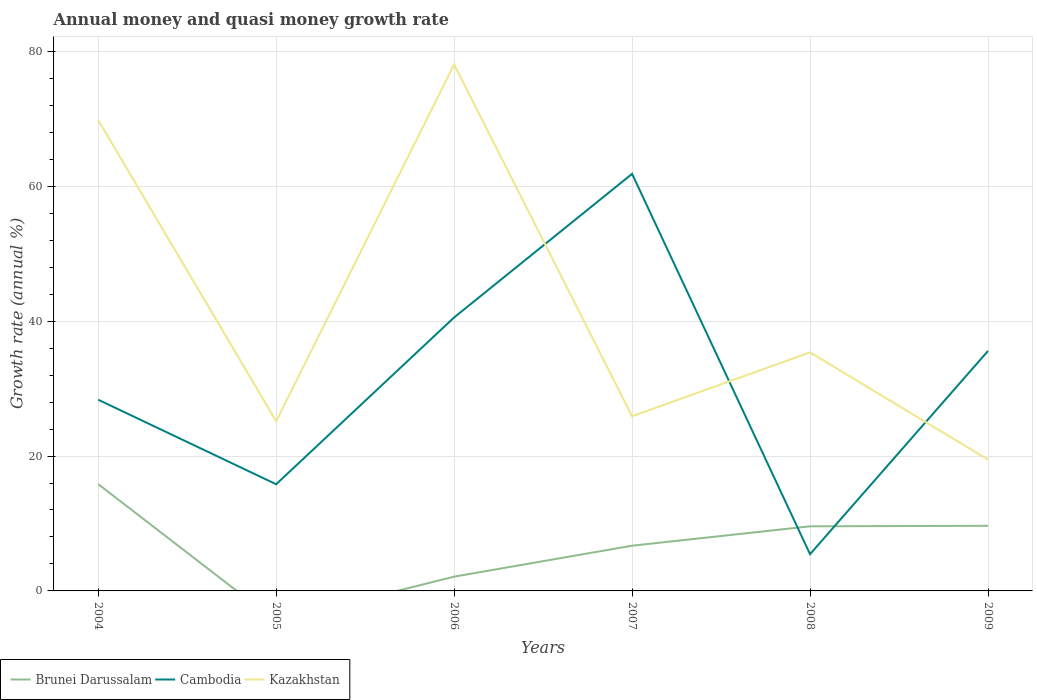How many different coloured lines are there?
Offer a terse response. 3. Is the number of lines equal to the number of legend labels?
Keep it short and to the point. No. Across all years, what is the maximum growth rate in Kazakhstan?
Your answer should be very brief. 19.47. What is the total growth rate in Cambodia in the graph?
Offer a very short reply. 26.25. What is the difference between the highest and the second highest growth rate in Cambodia?
Ensure brevity in your answer.  56.39. Is the growth rate in Cambodia strictly greater than the growth rate in Brunei Darussalam over the years?
Your answer should be compact. No. How many years are there in the graph?
Your answer should be very brief. 6. What is the difference between two consecutive major ticks on the Y-axis?
Your answer should be very brief. 20. How many legend labels are there?
Provide a short and direct response. 3. How are the legend labels stacked?
Give a very brief answer. Horizontal. What is the title of the graph?
Ensure brevity in your answer.  Annual money and quasi money growth rate. What is the label or title of the X-axis?
Your answer should be compact. Years. What is the label or title of the Y-axis?
Offer a terse response. Growth rate (annual %). What is the Growth rate (annual %) in Brunei Darussalam in 2004?
Give a very brief answer. 15.83. What is the Growth rate (annual %) in Cambodia in 2004?
Make the answer very short. 28.35. What is the Growth rate (annual %) of Kazakhstan in 2004?
Keep it short and to the point. 69.81. What is the Growth rate (annual %) of Brunei Darussalam in 2005?
Give a very brief answer. 0. What is the Growth rate (annual %) in Cambodia in 2005?
Your answer should be compact. 15.82. What is the Growth rate (annual %) in Kazakhstan in 2005?
Offer a terse response. 25.16. What is the Growth rate (annual %) of Brunei Darussalam in 2006?
Provide a succinct answer. 2.12. What is the Growth rate (annual %) of Cambodia in 2006?
Offer a very short reply. 40.55. What is the Growth rate (annual %) in Kazakhstan in 2006?
Offer a very short reply. 78.06. What is the Growth rate (annual %) in Brunei Darussalam in 2007?
Ensure brevity in your answer.  6.71. What is the Growth rate (annual %) of Cambodia in 2007?
Offer a terse response. 61.84. What is the Growth rate (annual %) in Kazakhstan in 2007?
Provide a succinct answer. 25.89. What is the Growth rate (annual %) in Brunei Darussalam in 2008?
Offer a terse response. 9.58. What is the Growth rate (annual %) in Cambodia in 2008?
Your answer should be compact. 5.45. What is the Growth rate (annual %) of Kazakhstan in 2008?
Your answer should be compact. 35.37. What is the Growth rate (annual %) in Brunei Darussalam in 2009?
Your answer should be compact. 9.66. What is the Growth rate (annual %) of Cambodia in 2009?
Offer a terse response. 35.58. What is the Growth rate (annual %) of Kazakhstan in 2009?
Your answer should be compact. 19.47. Across all years, what is the maximum Growth rate (annual %) of Brunei Darussalam?
Provide a succinct answer. 15.83. Across all years, what is the maximum Growth rate (annual %) of Cambodia?
Give a very brief answer. 61.84. Across all years, what is the maximum Growth rate (annual %) in Kazakhstan?
Your response must be concise. 78.06. Across all years, what is the minimum Growth rate (annual %) of Cambodia?
Offer a very short reply. 5.45. Across all years, what is the minimum Growth rate (annual %) in Kazakhstan?
Offer a very short reply. 19.47. What is the total Growth rate (annual %) of Brunei Darussalam in the graph?
Your response must be concise. 43.89. What is the total Growth rate (annual %) in Cambodia in the graph?
Offer a terse response. 187.58. What is the total Growth rate (annual %) in Kazakhstan in the graph?
Provide a short and direct response. 253.76. What is the difference between the Growth rate (annual %) in Cambodia in 2004 and that in 2005?
Your answer should be very brief. 12.53. What is the difference between the Growth rate (annual %) in Kazakhstan in 2004 and that in 2005?
Give a very brief answer. 44.64. What is the difference between the Growth rate (annual %) of Brunei Darussalam in 2004 and that in 2006?
Offer a very short reply. 13.72. What is the difference between the Growth rate (annual %) of Cambodia in 2004 and that in 2006?
Offer a very short reply. -12.2. What is the difference between the Growth rate (annual %) in Kazakhstan in 2004 and that in 2006?
Your response must be concise. -8.25. What is the difference between the Growth rate (annual %) of Brunei Darussalam in 2004 and that in 2007?
Your answer should be compact. 9.13. What is the difference between the Growth rate (annual %) in Cambodia in 2004 and that in 2007?
Give a very brief answer. -33.49. What is the difference between the Growth rate (annual %) of Kazakhstan in 2004 and that in 2007?
Ensure brevity in your answer.  43.91. What is the difference between the Growth rate (annual %) in Brunei Darussalam in 2004 and that in 2008?
Give a very brief answer. 6.26. What is the difference between the Growth rate (annual %) of Cambodia in 2004 and that in 2008?
Keep it short and to the point. 22.9. What is the difference between the Growth rate (annual %) of Kazakhstan in 2004 and that in 2008?
Offer a very short reply. 34.44. What is the difference between the Growth rate (annual %) in Brunei Darussalam in 2004 and that in 2009?
Your answer should be very brief. 6.18. What is the difference between the Growth rate (annual %) in Cambodia in 2004 and that in 2009?
Your response must be concise. -7.23. What is the difference between the Growth rate (annual %) in Kazakhstan in 2004 and that in 2009?
Offer a terse response. 50.34. What is the difference between the Growth rate (annual %) of Cambodia in 2005 and that in 2006?
Your answer should be compact. -24.73. What is the difference between the Growth rate (annual %) in Kazakhstan in 2005 and that in 2006?
Offer a very short reply. -52.9. What is the difference between the Growth rate (annual %) in Cambodia in 2005 and that in 2007?
Ensure brevity in your answer.  -46.02. What is the difference between the Growth rate (annual %) in Kazakhstan in 2005 and that in 2007?
Offer a very short reply. -0.73. What is the difference between the Growth rate (annual %) in Cambodia in 2005 and that in 2008?
Provide a succinct answer. 10.37. What is the difference between the Growth rate (annual %) in Kazakhstan in 2005 and that in 2008?
Provide a succinct answer. -10.2. What is the difference between the Growth rate (annual %) of Cambodia in 2005 and that in 2009?
Give a very brief answer. -19.77. What is the difference between the Growth rate (annual %) of Kazakhstan in 2005 and that in 2009?
Your response must be concise. 5.7. What is the difference between the Growth rate (annual %) of Brunei Darussalam in 2006 and that in 2007?
Give a very brief answer. -4.59. What is the difference between the Growth rate (annual %) of Cambodia in 2006 and that in 2007?
Make the answer very short. -21.29. What is the difference between the Growth rate (annual %) of Kazakhstan in 2006 and that in 2007?
Make the answer very short. 52.17. What is the difference between the Growth rate (annual %) of Brunei Darussalam in 2006 and that in 2008?
Your answer should be very brief. -7.46. What is the difference between the Growth rate (annual %) of Cambodia in 2006 and that in 2008?
Your response must be concise. 35.1. What is the difference between the Growth rate (annual %) of Kazakhstan in 2006 and that in 2008?
Your response must be concise. 42.69. What is the difference between the Growth rate (annual %) in Brunei Darussalam in 2006 and that in 2009?
Provide a succinct answer. -7.54. What is the difference between the Growth rate (annual %) of Cambodia in 2006 and that in 2009?
Your response must be concise. 4.96. What is the difference between the Growth rate (annual %) of Kazakhstan in 2006 and that in 2009?
Provide a short and direct response. 58.59. What is the difference between the Growth rate (annual %) of Brunei Darussalam in 2007 and that in 2008?
Keep it short and to the point. -2.87. What is the difference between the Growth rate (annual %) in Cambodia in 2007 and that in 2008?
Provide a succinct answer. 56.39. What is the difference between the Growth rate (annual %) of Kazakhstan in 2007 and that in 2008?
Provide a succinct answer. -9.47. What is the difference between the Growth rate (annual %) in Brunei Darussalam in 2007 and that in 2009?
Offer a very short reply. -2.95. What is the difference between the Growth rate (annual %) of Cambodia in 2007 and that in 2009?
Keep it short and to the point. 26.25. What is the difference between the Growth rate (annual %) of Kazakhstan in 2007 and that in 2009?
Provide a succinct answer. 6.43. What is the difference between the Growth rate (annual %) of Brunei Darussalam in 2008 and that in 2009?
Your answer should be compact. -0.08. What is the difference between the Growth rate (annual %) in Cambodia in 2008 and that in 2009?
Make the answer very short. -30.14. What is the difference between the Growth rate (annual %) of Kazakhstan in 2008 and that in 2009?
Make the answer very short. 15.9. What is the difference between the Growth rate (annual %) in Brunei Darussalam in 2004 and the Growth rate (annual %) in Cambodia in 2005?
Keep it short and to the point. 0.02. What is the difference between the Growth rate (annual %) of Brunei Darussalam in 2004 and the Growth rate (annual %) of Kazakhstan in 2005?
Give a very brief answer. -9.33. What is the difference between the Growth rate (annual %) of Cambodia in 2004 and the Growth rate (annual %) of Kazakhstan in 2005?
Your response must be concise. 3.18. What is the difference between the Growth rate (annual %) of Brunei Darussalam in 2004 and the Growth rate (annual %) of Cambodia in 2006?
Your answer should be compact. -24.71. What is the difference between the Growth rate (annual %) of Brunei Darussalam in 2004 and the Growth rate (annual %) of Kazakhstan in 2006?
Give a very brief answer. -62.23. What is the difference between the Growth rate (annual %) in Cambodia in 2004 and the Growth rate (annual %) in Kazakhstan in 2006?
Make the answer very short. -49.71. What is the difference between the Growth rate (annual %) of Brunei Darussalam in 2004 and the Growth rate (annual %) of Cambodia in 2007?
Offer a very short reply. -46. What is the difference between the Growth rate (annual %) in Brunei Darussalam in 2004 and the Growth rate (annual %) in Kazakhstan in 2007?
Your answer should be compact. -10.06. What is the difference between the Growth rate (annual %) of Cambodia in 2004 and the Growth rate (annual %) of Kazakhstan in 2007?
Ensure brevity in your answer.  2.45. What is the difference between the Growth rate (annual %) in Brunei Darussalam in 2004 and the Growth rate (annual %) in Cambodia in 2008?
Your answer should be compact. 10.39. What is the difference between the Growth rate (annual %) of Brunei Darussalam in 2004 and the Growth rate (annual %) of Kazakhstan in 2008?
Offer a very short reply. -19.53. What is the difference between the Growth rate (annual %) in Cambodia in 2004 and the Growth rate (annual %) in Kazakhstan in 2008?
Your answer should be compact. -7.02. What is the difference between the Growth rate (annual %) of Brunei Darussalam in 2004 and the Growth rate (annual %) of Cambodia in 2009?
Give a very brief answer. -19.75. What is the difference between the Growth rate (annual %) of Brunei Darussalam in 2004 and the Growth rate (annual %) of Kazakhstan in 2009?
Make the answer very short. -3.63. What is the difference between the Growth rate (annual %) of Cambodia in 2004 and the Growth rate (annual %) of Kazakhstan in 2009?
Ensure brevity in your answer.  8.88. What is the difference between the Growth rate (annual %) of Cambodia in 2005 and the Growth rate (annual %) of Kazakhstan in 2006?
Ensure brevity in your answer.  -62.24. What is the difference between the Growth rate (annual %) in Cambodia in 2005 and the Growth rate (annual %) in Kazakhstan in 2007?
Make the answer very short. -10.08. What is the difference between the Growth rate (annual %) of Cambodia in 2005 and the Growth rate (annual %) of Kazakhstan in 2008?
Your answer should be very brief. -19.55. What is the difference between the Growth rate (annual %) of Cambodia in 2005 and the Growth rate (annual %) of Kazakhstan in 2009?
Keep it short and to the point. -3.65. What is the difference between the Growth rate (annual %) of Brunei Darussalam in 2006 and the Growth rate (annual %) of Cambodia in 2007?
Your answer should be compact. -59.72. What is the difference between the Growth rate (annual %) of Brunei Darussalam in 2006 and the Growth rate (annual %) of Kazakhstan in 2007?
Your answer should be compact. -23.78. What is the difference between the Growth rate (annual %) of Cambodia in 2006 and the Growth rate (annual %) of Kazakhstan in 2007?
Give a very brief answer. 14.65. What is the difference between the Growth rate (annual %) of Brunei Darussalam in 2006 and the Growth rate (annual %) of Cambodia in 2008?
Offer a terse response. -3.33. What is the difference between the Growth rate (annual %) of Brunei Darussalam in 2006 and the Growth rate (annual %) of Kazakhstan in 2008?
Offer a terse response. -33.25. What is the difference between the Growth rate (annual %) in Cambodia in 2006 and the Growth rate (annual %) in Kazakhstan in 2008?
Offer a terse response. 5.18. What is the difference between the Growth rate (annual %) in Brunei Darussalam in 2006 and the Growth rate (annual %) in Cambodia in 2009?
Ensure brevity in your answer.  -33.47. What is the difference between the Growth rate (annual %) of Brunei Darussalam in 2006 and the Growth rate (annual %) of Kazakhstan in 2009?
Provide a succinct answer. -17.35. What is the difference between the Growth rate (annual %) of Cambodia in 2006 and the Growth rate (annual %) of Kazakhstan in 2009?
Offer a very short reply. 21.08. What is the difference between the Growth rate (annual %) in Brunei Darussalam in 2007 and the Growth rate (annual %) in Cambodia in 2008?
Offer a very short reply. 1.26. What is the difference between the Growth rate (annual %) of Brunei Darussalam in 2007 and the Growth rate (annual %) of Kazakhstan in 2008?
Give a very brief answer. -28.66. What is the difference between the Growth rate (annual %) in Cambodia in 2007 and the Growth rate (annual %) in Kazakhstan in 2008?
Provide a succinct answer. 26.47. What is the difference between the Growth rate (annual %) of Brunei Darussalam in 2007 and the Growth rate (annual %) of Cambodia in 2009?
Your answer should be very brief. -28.88. What is the difference between the Growth rate (annual %) of Brunei Darussalam in 2007 and the Growth rate (annual %) of Kazakhstan in 2009?
Provide a short and direct response. -12.76. What is the difference between the Growth rate (annual %) of Cambodia in 2007 and the Growth rate (annual %) of Kazakhstan in 2009?
Offer a terse response. 42.37. What is the difference between the Growth rate (annual %) of Brunei Darussalam in 2008 and the Growth rate (annual %) of Cambodia in 2009?
Offer a very short reply. -26. What is the difference between the Growth rate (annual %) of Brunei Darussalam in 2008 and the Growth rate (annual %) of Kazakhstan in 2009?
Your answer should be very brief. -9.89. What is the difference between the Growth rate (annual %) in Cambodia in 2008 and the Growth rate (annual %) in Kazakhstan in 2009?
Provide a succinct answer. -14.02. What is the average Growth rate (annual %) of Brunei Darussalam per year?
Make the answer very short. 7.32. What is the average Growth rate (annual %) of Cambodia per year?
Your answer should be very brief. 31.26. What is the average Growth rate (annual %) of Kazakhstan per year?
Keep it short and to the point. 42.29. In the year 2004, what is the difference between the Growth rate (annual %) in Brunei Darussalam and Growth rate (annual %) in Cambodia?
Provide a short and direct response. -12.51. In the year 2004, what is the difference between the Growth rate (annual %) of Brunei Darussalam and Growth rate (annual %) of Kazakhstan?
Offer a terse response. -53.97. In the year 2004, what is the difference between the Growth rate (annual %) of Cambodia and Growth rate (annual %) of Kazakhstan?
Give a very brief answer. -41.46. In the year 2005, what is the difference between the Growth rate (annual %) of Cambodia and Growth rate (annual %) of Kazakhstan?
Provide a succinct answer. -9.35. In the year 2006, what is the difference between the Growth rate (annual %) in Brunei Darussalam and Growth rate (annual %) in Cambodia?
Offer a very short reply. -38.43. In the year 2006, what is the difference between the Growth rate (annual %) in Brunei Darussalam and Growth rate (annual %) in Kazakhstan?
Your answer should be very brief. -75.94. In the year 2006, what is the difference between the Growth rate (annual %) in Cambodia and Growth rate (annual %) in Kazakhstan?
Your answer should be very brief. -37.51. In the year 2007, what is the difference between the Growth rate (annual %) of Brunei Darussalam and Growth rate (annual %) of Cambodia?
Keep it short and to the point. -55.13. In the year 2007, what is the difference between the Growth rate (annual %) of Brunei Darussalam and Growth rate (annual %) of Kazakhstan?
Your answer should be very brief. -19.19. In the year 2007, what is the difference between the Growth rate (annual %) in Cambodia and Growth rate (annual %) in Kazakhstan?
Keep it short and to the point. 35.94. In the year 2008, what is the difference between the Growth rate (annual %) in Brunei Darussalam and Growth rate (annual %) in Cambodia?
Your answer should be compact. 4.13. In the year 2008, what is the difference between the Growth rate (annual %) of Brunei Darussalam and Growth rate (annual %) of Kazakhstan?
Provide a short and direct response. -25.79. In the year 2008, what is the difference between the Growth rate (annual %) of Cambodia and Growth rate (annual %) of Kazakhstan?
Your answer should be compact. -29.92. In the year 2009, what is the difference between the Growth rate (annual %) of Brunei Darussalam and Growth rate (annual %) of Cambodia?
Your answer should be very brief. -25.93. In the year 2009, what is the difference between the Growth rate (annual %) in Brunei Darussalam and Growth rate (annual %) in Kazakhstan?
Your answer should be very brief. -9.81. In the year 2009, what is the difference between the Growth rate (annual %) in Cambodia and Growth rate (annual %) in Kazakhstan?
Provide a short and direct response. 16.11. What is the ratio of the Growth rate (annual %) of Cambodia in 2004 to that in 2005?
Ensure brevity in your answer.  1.79. What is the ratio of the Growth rate (annual %) in Kazakhstan in 2004 to that in 2005?
Ensure brevity in your answer.  2.77. What is the ratio of the Growth rate (annual %) in Brunei Darussalam in 2004 to that in 2006?
Your answer should be compact. 7.48. What is the ratio of the Growth rate (annual %) of Cambodia in 2004 to that in 2006?
Ensure brevity in your answer.  0.7. What is the ratio of the Growth rate (annual %) of Kazakhstan in 2004 to that in 2006?
Keep it short and to the point. 0.89. What is the ratio of the Growth rate (annual %) of Brunei Darussalam in 2004 to that in 2007?
Ensure brevity in your answer.  2.36. What is the ratio of the Growth rate (annual %) in Cambodia in 2004 to that in 2007?
Provide a short and direct response. 0.46. What is the ratio of the Growth rate (annual %) of Kazakhstan in 2004 to that in 2007?
Provide a short and direct response. 2.7. What is the ratio of the Growth rate (annual %) of Brunei Darussalam in 2004 to that in 2008?
Offer a terse response. 1.65. What is the ratio of the Growth rate (annual %) of Cambodia in 2004 to that in 2008?
Keep it short and to the point. 5.21. What is the ratio of the Growth rate (annual %) of Kazakhstan in 2004 to that in 2008?
Offer a terse response. 1.97. What is the ratio of the Growth rate (annual %) in Brunei Darussalam in 2004 to that in 2009?
Your answer should be compact. 1.64. What is the ratio of the Growth rate (annual %) in Cambodia in 2004 to that in 2009?
Provide a succinct answer. 0.8. What is the ratio of the Growth rate (annual %) of Kazakhstan in 2004 to that in 2009?
Provide a succinct answer. 3.59. What is the ratio of the Growth rate (annual %) in Cambodia in 2005 to that in 2006?
Ensure brevity in your answer.  0.39. What is the ratio of the Growth rate (annual %) in Kazakhstan in 2005 to that in 2006?
Make the answer very short. 0.32. What is the ratio of the Growth rate (annual %) of Cambodia in 2005 to that in 2007?
Your answer should be compact. 0.26. What is the ratio of the Growth rate (annual %) of Kazakhstan in 2005 to that in 2007?
Keep it short and to the point. 0.97. What is the ratio of the Growth rate (annual %) in Cambodia in 2005 to that in 2008?
Give a very brief answer. 2.9. What is the ratio of the Growth rate (annual %) in Kazakhstan in 2005 to that in 2008?
Provide a succinct answer. 0.71. What is the ratio of the Growth rate (annual %) of Cambodia in 2005 to that in 2009?
Provide a succinct answer. 0.44. What is the ratio of the Growth rate (annual %) of Kazakhstan in 2005 to that in 2009?
Your answer should be compact. 1.29. What is the ratio of the Growth rate (annual %) in Brunei Darussalam in 2006 to that in 2007?
Ensure brevity in your answer.  0.32. What is the ratio of the Growth rate (annual %) of Cambodia in 2006 to that in 2007?
Offer a terse response. 0.66. What is the ratio of the Growth rate (annual %) of Kazakhstan in 2006 to that in 2007?
Your answer should be very brief. 3.01. What is the ratio of the Growth rate (annual %) in Brunei Darussalam in 2006 to that in 2008?
Offer a terse response. 0.22. What is the ratio of the Growth rate (annual %) in Cambodia in 2006 to that in 2008?
Make the answer very short. 7.45. What is the ratio of the Growth rate (annual %) in Kazakhstan in 2006 to that in 2008?
Make the answer very short. 2.21. What is the ratio of the Growth rate (annual %) of Brunei Darussalam in 2006 to that in 2009?
Offer a very short reply. 0.22. What is the ratio of the Growth rate (annual %) in Cambodia in 2006 to that in 2009?
Provide a succinct answer. 1.14. What is the ratio of the Growth rate (annual %) of Kazakhstan in 2006 to that in 2009?
Your answer should be very brief. 4.01. What is the ratio of the Growth rate (annual %) in Brunei Darussalam in 2007 to that in 2008?
Your answer should be compact. 0.7. What is the ratio of the Growth rate (annual %) of Cambodia in 2007 to that in 2008?
Give a very brief answer. 11.35. What is the ratio of the Growth rate (annual %) in Kazakhstan in 2007 to that in 2008?
Keep it short and to the point. 0.73. What is the ratio of the Growth rate (annual %) of Brunei Darussalam in 2007 to that in 2009?
Offer a terse response. 0.69. What is the ratio of the Growth rate (annual %) in Cambodia in 2007 to that in 2009?
Provide a short and direct response. 1.74. What is the ratio of the Growth rate (annual %) in Kazakhstan in 2007 to that in 2009?
Your response must be concise. 1.33. What is the ratio of the Growth rate (annual %) in Brunei Darussalam in 2008 to that in 2009?
Your answer should be very brief. 0.99. What is the ratio of the Growth rate (annual %) in Cambodia in 2008 to that in 2009?
Offer a very short reply. 0.15. What is the ratio of the Growth rate (annual %) of Kazakhstan in 2008 to that in 2009?
Offer a terse response. 1.82. What is the difference between the highest and the second highest Growth rate (annual %) in Brunei Darussalam?
Make the answer very short. 6.18. What is the difference between the highest and the second highest Growth rate (annual %) of Cambodia?
Keep it short and to the point. 21.29. What is the difference between the highest and the second highest Growth rate (annual %) in Kazakhstan?
Provide a succinct answer. 8.25. What is the difference between the highest and the lowest Growth rate (annual %) in Brunei Darussalam?
Your answer should be very brief. 15.83. What is the difference between the highest and the lowest Growth rate (annual %) of Cambodia?
Offer a terse response. 56.39. What is the difference between the highest and the lowest Growth rate (annual %) in Kazakhstan?
Provide a short and direct response. 58.59. 